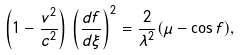Convert formula to latex. <formula><loc_0><loc_0><loc_500><loc_500>\left ( 1 - \frac { v ^ { 2 } } { c ^ { 2 } } \right ) \, \left ( \frac { d f } { d \xi } \right ) ^ { 2 } = \frac { 2 } { \lambda ^ { 2 } } ( \mu - \cos { f } ) ,</formula> 